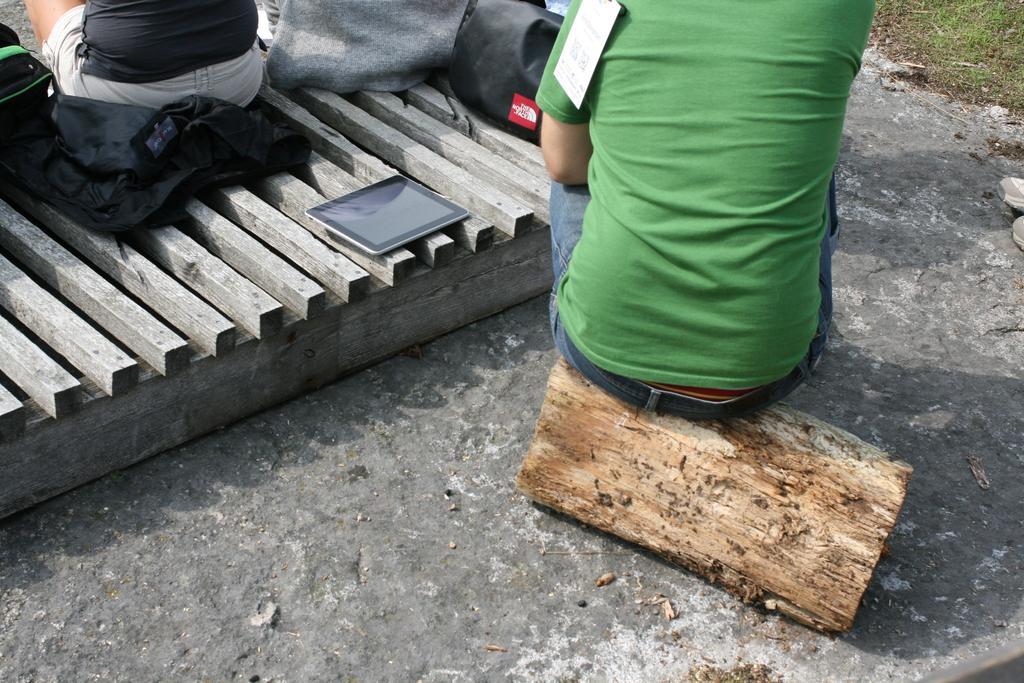Please provide a concise description of this image. In this image I can see few people sitting on the wooden object. These people are wearing the different color dresses. I can see the bags and some clothes and also iPad on the wooden object. To the side I can see the ground. 